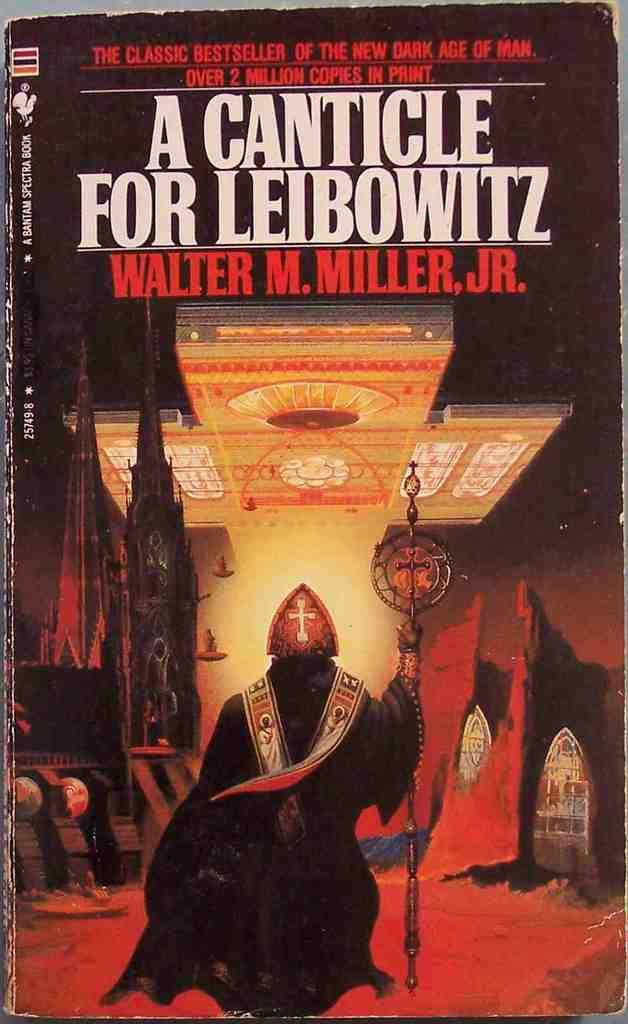<image>
Share a concise interpretation of the image provided. The front cover of Walter M. Miller jr's A Canticle for Leibowitz shows a robed and masked figure holding a scepter. 